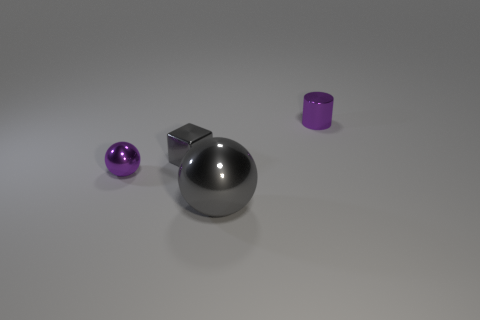Subtract all red spheres. Subtract all cyan cubes. How many spheres are left? 2 Add 2 purple cylinders. How many objects exist? 6 Subtract all blocks. How many objects are left? 3 Add 4 tiny cyan balls. How many tiny cyan balls exist? 4 Subtract 0 blue blocks. How many objects are left? 4 Subtract all purple shiny spheres. Subtract all tiny balls. How many objects are left? 2 Add 2 small gray metal objects. How many small gray metal objects are left? 3 